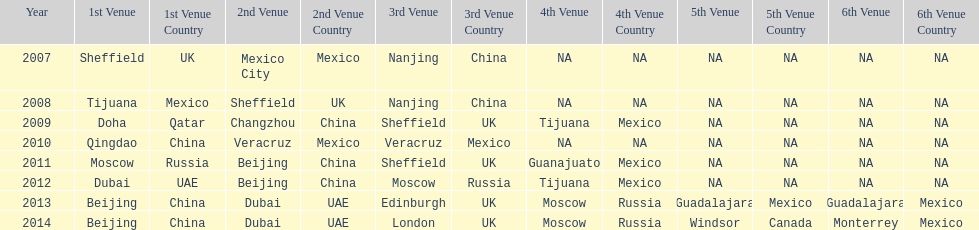How long, in years, has the this world series been occurring? 7 years. Could you help me parse every detail presented in this table? {'header': ['Year', '1st Venue', '1st Venue Country', '2nd Venue', '2nd Venue Country', '3rd Venue', '3rd Venue Country', '4th Venue', '4th Venue Country', '5th Venue', '5th Venue Country', '6th Venue', '6th Venue Country'], 'rows': [['2007', 'Sheffield', 'UK', 'Mexico City', 'Mexico', 'Nanjing', 'China', 'NA', 'NA', 'NA', 'NA', 'NA', 'NA'], ['2008', 'Tijuana', 'Mexico', 'Sheffield', 'UK', 'Nanjing', 'China', 'NA', 'NA', 'NA', 'NA', 'NA', 'NA'], ['2009', 'Doha', 'Qatar', 'Changzhou', 'China', 'Sheffield', 'UK', 'Tijuana', 'Mexico', 'NA', 'NA', 'NA', 'NA'], ['2010', 'Qingdao', 'China', 'Veracruz', 'Mexico', 'Veracruz', 'Mexico', 'NA', 'NA', 'NA', 'NA', 'NA', 'NA'], ['2011', 'Moscow', 'Russia', 'Beijing', 'China', 'Sheffield', 'UK', 'Guanajuato', 'Mexico', 'NA', 'NA', 'NA', 'NA'], ['2012', 'Dubai', 'UAE', 'Beijing', 'China', 'Moscow', 'Russia', 'Tijuana', 'Mexico', 'NA', 'NA', 'NA', 'NA'], ['2013', 'Beijing', 'China', 'Dubai', 'UAE', 'Edinburgh', 'UK', 'Moscow', 'Russia', 'Guadalajara', 'Mexico', 'Guadalajara', 'Mexico'], ['2014', 'Beijing', 'China', 'Dubai', 'UAE', 'London', 'UK', 'Moscow', 'Russia', 'Windsor', 'Canada', 'Monterrey', 'Mexico']]} 